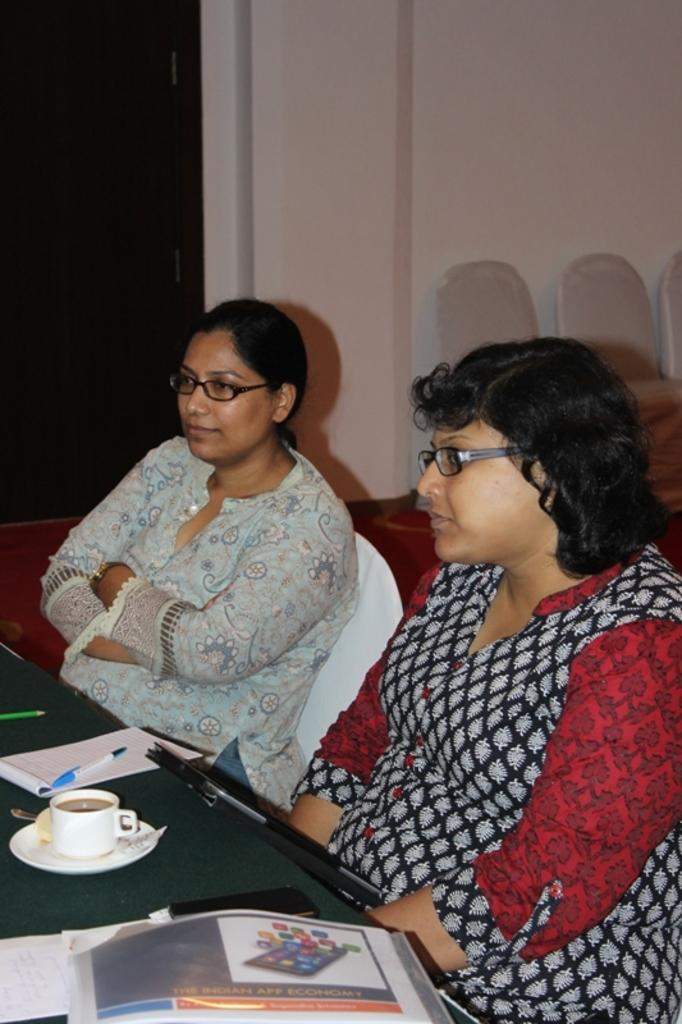How many people are in the image? There are two women in the image. What are the women doing in the image? The women are sitting in chairs. Where are the chairs located in the image? The chairs are at a table. What type of structure is the lawyer working on in the image? There is no lawyer or structure present in the image; it features two women sitting in chairs at a table. 